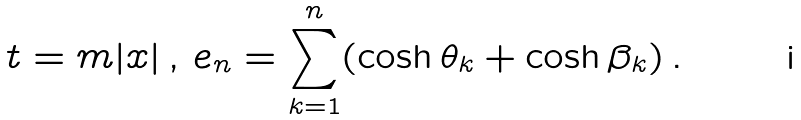Convert formula to latex. <formula><loc_0><loc_0><loc_500><loc_500>t = m | x | \, , \, e _ { n } = \sum _ { k = 1 } ^ { n } ( \cosh \theta _ { k } + \cosh \beta _ { k } ) \, .</formula> 